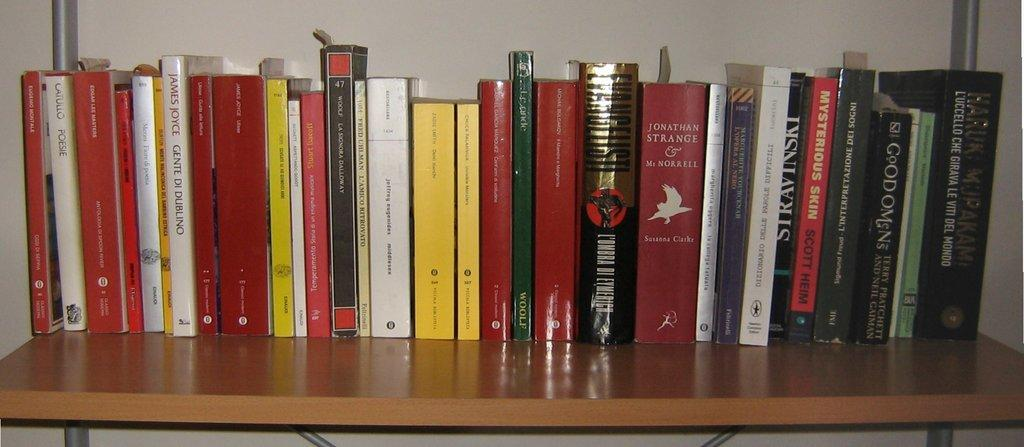What objects can be seen on the shelf in the image? There are many books present on the shelf. What is located behind the books on the shelf? There is a wall behind the books. What type of cloth can be seen hanging from the gate in the image? There is no gate or cloth present in the image; it only features books on a shelf with a wall behind them. 